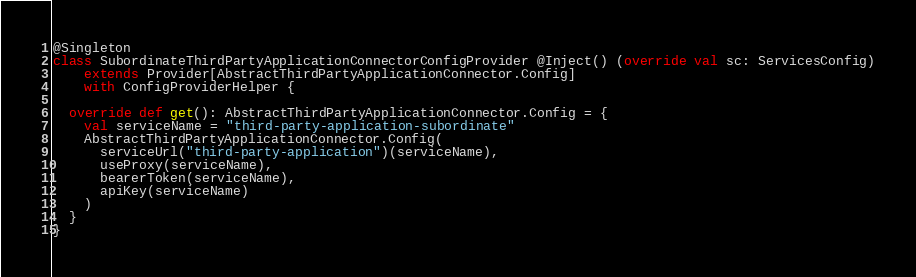<code> <loc_0><loc_0><loc_500><loc_500><_Scala_>@Singleton
class SubordinateThirdPartyApplicationConnectorConfigProvider @Inject() (override val sc: ServicesConfig)
    extends Provider[AbstractThirdPartyApplicationConnector.Config]
    with ConfigProviderHelper {

  override def get(): AbstractThirdPartyApplicationConnector.Config = {
    val serviceName = "third-party-application-subordinate"
    AbstractThirdPartyApplicationConnector.Config(
      serviceUrl("third-party-application")(serviceName),
      useProxy(serviceName),
      bearerToken(serviceName),
      apiKey(serviceName)
    )
  }
}
</code> 